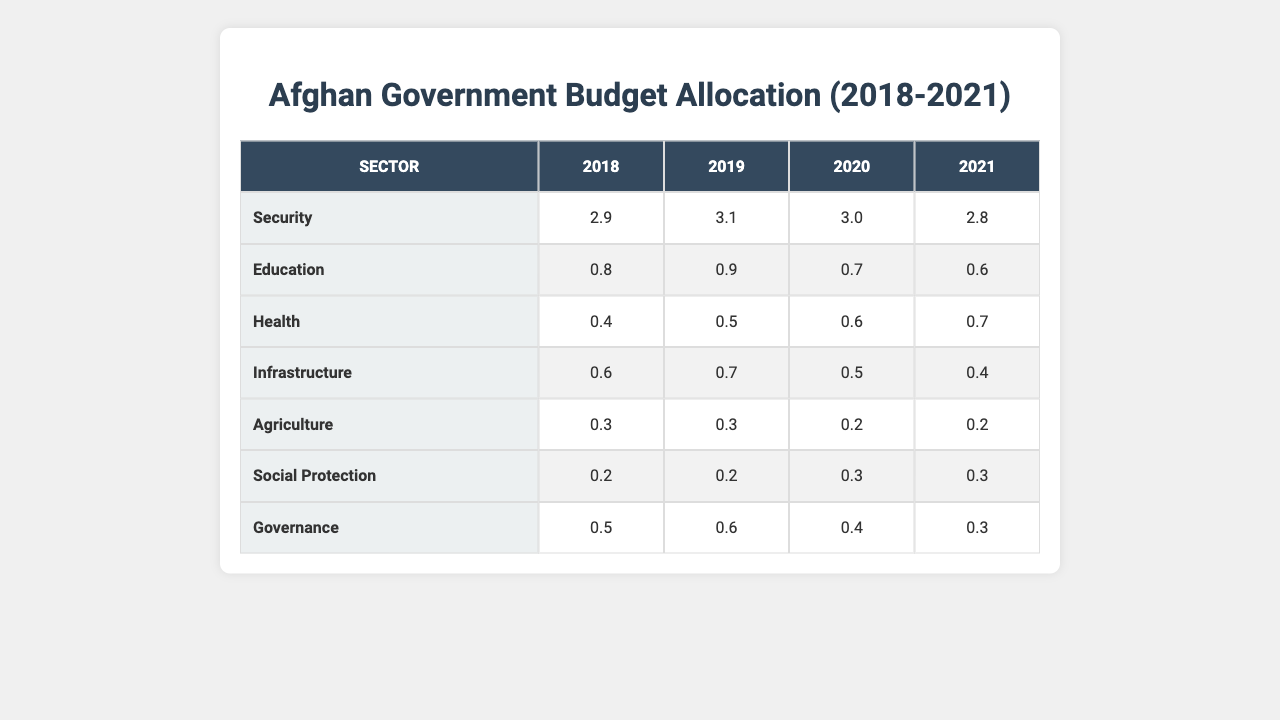What was the budget allocation for Education in 2020? The table shows that the budget allocation for Education in 2020 is 0.7.
Answer: 0.7 Which sector received the highest budget in 2019? According to the table, the highest budget allocation in 2019 was for Security with 3.1.
Answer: Security What is the total budget allocation for Health from 2018 to 2021? Adding the budget allocation for Health across the years: 0.4 (2018) + 0.5 (2019) + 0.6 (2020) + 0.7 (2021) results in a total of 2.2.
Answer: 2.2 Did the budget for Agriculture increase from 2018 to 2021? The budget for Agriculture was 0.3 in 2018 and 0.2 in 2021, indicating a decrease.
Answer: No What was the difference between the Security budget in 2018 and 2021? The budget for Security in 2018 was 2.9, and in 2021 it was 2.8. The difference is 2.9 - 2.8 = 0.1.
Answer: 0.1 What is the average budget allocation for Social Protection over the four years? To find the average, sum the allocations: 0.2 (2018) + 0.2 (2019) + 0.3 (2020) + 0.3 (2021) = 1.0. Then divide by 4 (number of years), resulting in an average of 1.0 / 4 = 0.25.
Answer: 0.25 Which sector saw the largest decrease in budget allocation from 2018 to 2021? By comparing year-to-year allocations, the Security sector decreased from 2.9 in 2018 to 2.8 in 2021, while Education went from 0.8 to 0.6. The Security sector had a more significant impact despite a smaller difference (0.1) compared to Education (0.2).
Answer: Security Was there a year in which the Health budget was higher than the Education budget? The table indicates that in 2019 the Health budget was 0.5 while Education was 0.9. In 2020, Health (0.6) surpassed Education (0.7), and in 2021, Health (0.7) also exceeded Education (0.6). Thus, Health was higher in both 2020 and 2021.
Answer: Yes What is the total budget allocation for Governance from 2018 to 2021? The Governance budget allocations are 0.5 (2018), 0.6 (2019), 0.4 (2020), and 0.3 (2021). Therefore, 0.5 + 0.6 + 0.4 + 0.3 = 1.8.
Answer: 1.8 In which year did Education have the lowest budget? The allocations are 0.8 (2018), 0.9 (2019), 0.7 (2020), and 0.6 (2021). The lowest budget for Education was in 2021 with 0.6.
Answer: 2021 